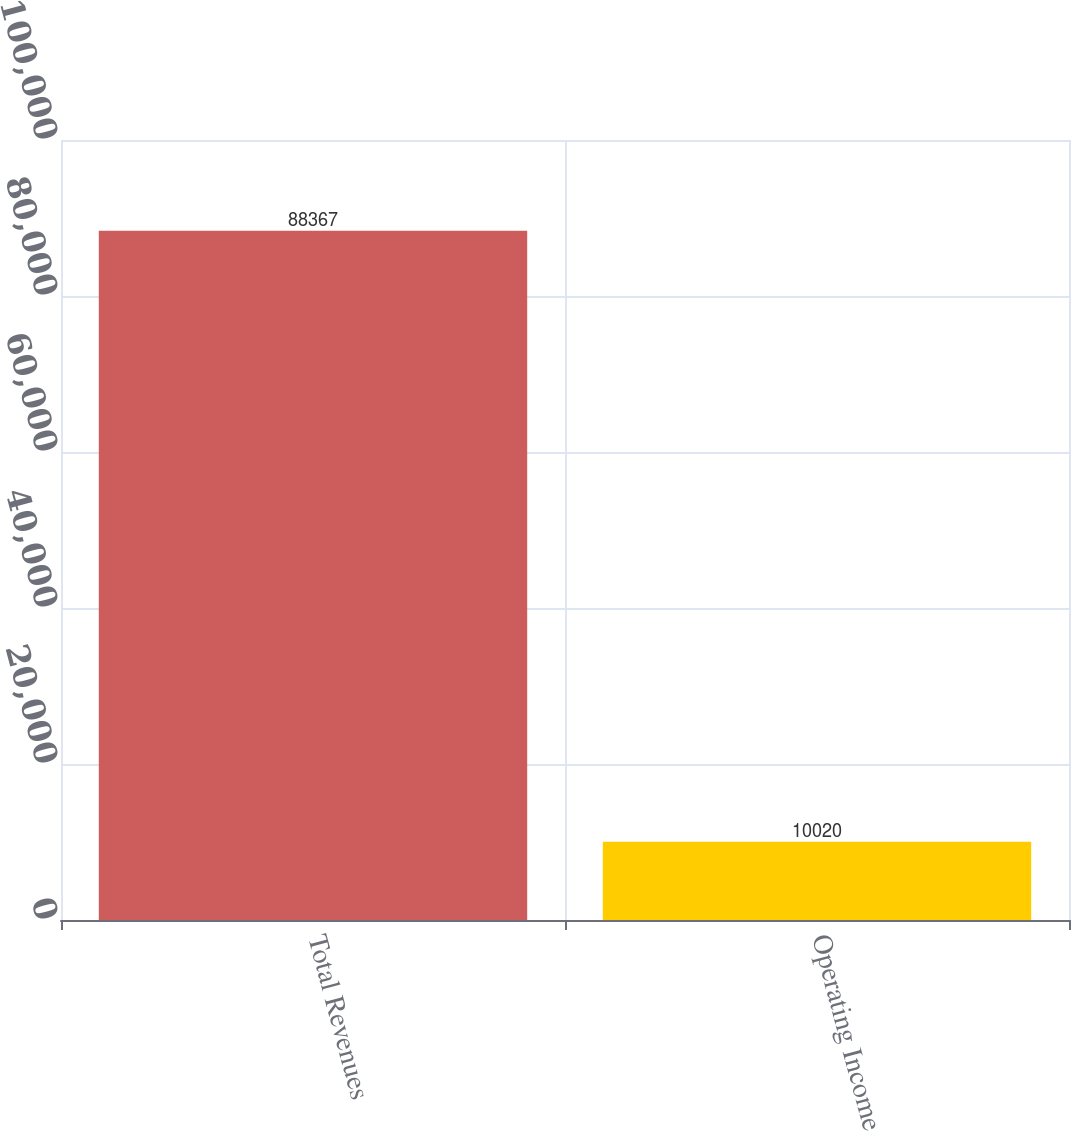Convert chart. <chart><loc_0><loc_0><loc_500><loc_500><bar_chart><fcel>Total Revenues<fcel>Operating Income<nl><fcel>88367<fcel>10020<nl></chart> 